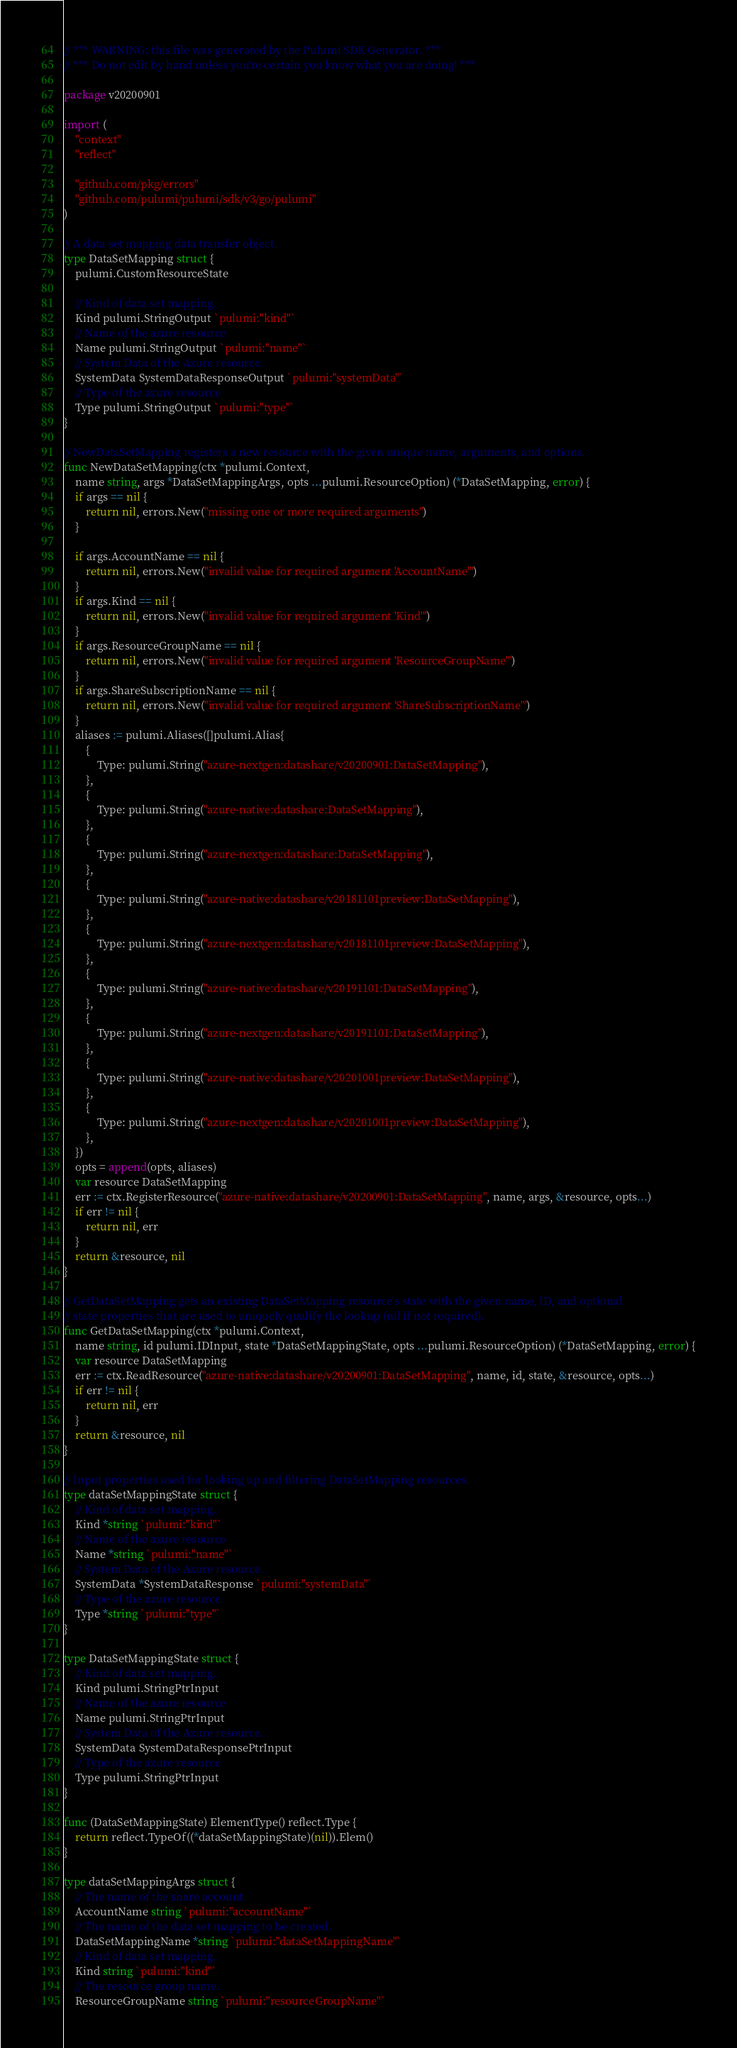Convert code to text. <code><loc_0><loc_0><loc_500><loc_500><_Go_>// *** WARNING: this file was generated by the Pulumi SDK Generator. ***
// *** Do not edit by hand unless you're certain you know what you are doing! ***

package v20200901

import (
	"context"
	"reflect"

	"github.com/pkg/errors"
	"github.com/pulumi/pulumi/sdk/v3/go/pulumi"
)

// A data set mapping data transfer object.
type DataSetMapping struct {
	pulumi.CustomResourceState

	// Kind of data set mapping.
	Kind pulumi.StringOutput `pulumi:"kind"`
	// Name of the azure resource
	Name pulumi.StringOutput `pulumi:"name"`
	// System Data of the Azure resource.
	SystemData SystemDataResponseOutput `pulumi:"systemData"`
	// Type of the azure resource
	Type pulumi.StringOutput `pulumi:"type"`
}

// NewDataSetMapping registers a new resource with the given unique name, arguments, and options.
func NewDataSetMapping(ctx *pulumi.Context,
	name string, args *DataSetMappingArgs, opts ...pulumi.ResourceOption) (*DataSetMapping, error) {
	if args == nil {
		return nil, errors.New("missing one or more required arguments")
	}

	if args.AccountName == nil {
		return nil, errors.New("invalid value for required argument 'AccountName'")
	}
	if args.Kind == nil {
		return nil, errors.New("invalid value for required argument 'Kind'")
	}
	if args.ResourceGroupName == nil {
		return nil, errors.New("invalid value for required argument 'ResourceGroupName'")
	}
	if args.ShareSubscriptionName == nil {
		return nil, errors.New("invalid value for required argument 'ShareSubscriptionName'")
	}
	aliases := pulumi.Aliases([]pulumi.Alias{
		{
			Type: pulumi.String("azure-nextgen:datashare/v20200901:DataSetMapping"),
		},
		{
			Type: pulumi.String("azure-native:datashare:DataSetMapping"),
		},
		{
			Type: pulumi.String("azure-nextgen:datashare:DataSetMapping"),
		},
		{
			Type: pulumi.String("azure-native:datashare/v20181101preview:DataSetMapping"),
		},
		{
			Type: pulumi.String("azure-nextgen:datashare/v20181101preview:DataSetMapping"),
		},
		{
			Type: pulumi.String("azure-native:datashare/v20191101:DataSetMapping"),
		},
		{
			Type: pulumi.String("azure-nextgen:datashare/v20191101:DataSetMapping"),
		},
		{
			Type: pulumi.String("azure-native:datashare/v20201001preview:DataSetMapping"),
		},
		{
			Type: pulumi.String("azure-nextgen:datashare/v20201001preview:DataSetMapping"),
		},
	})
	opts = append(opts, aliases)
	var resource DataSetMapping
	err := ctx.RegisterResource("azure-native:datashare/v20200901:DataSetMapping", name, args, &resource, opts...)
	if err != nil {
		return nil, err
	}
	return &resource, nil
}

// GetDataSetMapping gets an existing DataSetMapping resource's state with the given name, ID, and optional
// state properties that are used to uniquely qualify the lookup (nil if not required).
func GetDataSetMapping(ctx *pulumi.Context,
	name string, id pulumi.IDInput, state *DataSetMappingState, opts ...pulumi.ResourceOption) (*DataSetMapping, error) {
	var resource DataSetMapping
	err := ctx.ReadResource("azure-native:datashare/v20200901:DataSetMapping", name, id, state, &resource, opts...)
	if err != nil {
		return nil, err
	}
	return &resource, nil
}

// Input properties used for looking up and filtering DataSetMapping resources.
type dataSetMappingState struct {
	// Kind of data set mapping.
	Kind *string `pulumi:"kind"`
	// Name of the azure resource
	Name *string `pulumi:"name"`
	// System Data of the Azure resource.
	SystemData *SystemDataResponse `pulumi:"systemData"`
	// Type of the azure resource
	Type *string `pulumi:"type"`
}

type DataSetMappingState struct {
	// Kind of data set mapping.
	Kind pulumi.StringPtrInput
	// Name of the azure resource
	Name pulumi.StringPtrInput
	// System Data of the Azure resource.
	SystemData SystemDataResponsePtrInput
	// Type of the azure resource
	Type pulumi.StringPtrInput
}

func (DataSetMappingState) ElementType() reflect.Type {
	return reflect.TypeOf((*dataSetMappingState)(nil)).Elem()
}

type dataSetMappingArgs struct {
	// The name of the share account.
	AccountName string `pulumi:"accountName"`
	// The name of the data set mapping to be created.
	DataSetMappingName *string `pulumi:"dataSetMappingName"`
	// Kind of data set mapping.
	Kind string `pulumi:"kind"`
	// The resource group name.
	ResourceGroupName string `pulumi:"resourceGroupName"`</code> 